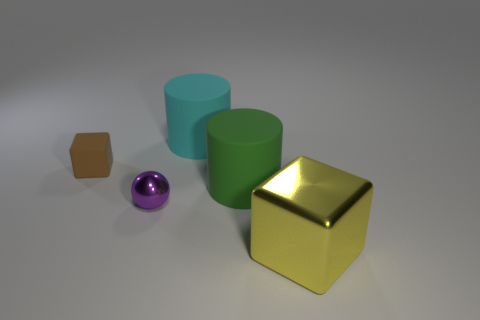Is the small ball made of the same material as the cube right of the green thing?
Provide a succinct answer. Yes. The cyan object that is the same shape as the big green object is what size?
Your answer should be compact. Large. Are there the same number of large green rubber cylinders that are to the left of the brown thing and purple shiny objects that are in front of the purple shiny thing?
Provide a succinct answer. Yes. How many other objects are there of the same material as the brown block?
Make the answer very short. 2. Are there an equal number of purple metallic objects on the left side of the sphere and metal cubes?
Give a very brief answer. No. There is a brown block; is it the same size as the rubber cylinder behind the small block?
Ensure brevity in your answer.  No. What is the shape of the tiny brown thing behind the green cylinder?
Your response must be concise. Cube. Are there any other things that have the same shape as the yellow metallic thing?
Your answer should be compact. Yes. Are there any tiny purple things?
Provide a succinct answer. Yes. There is a green thing behind the tiny metal object; does it have the same size as the block that is behind the green matte thing?
Your answer should be compact. No. 